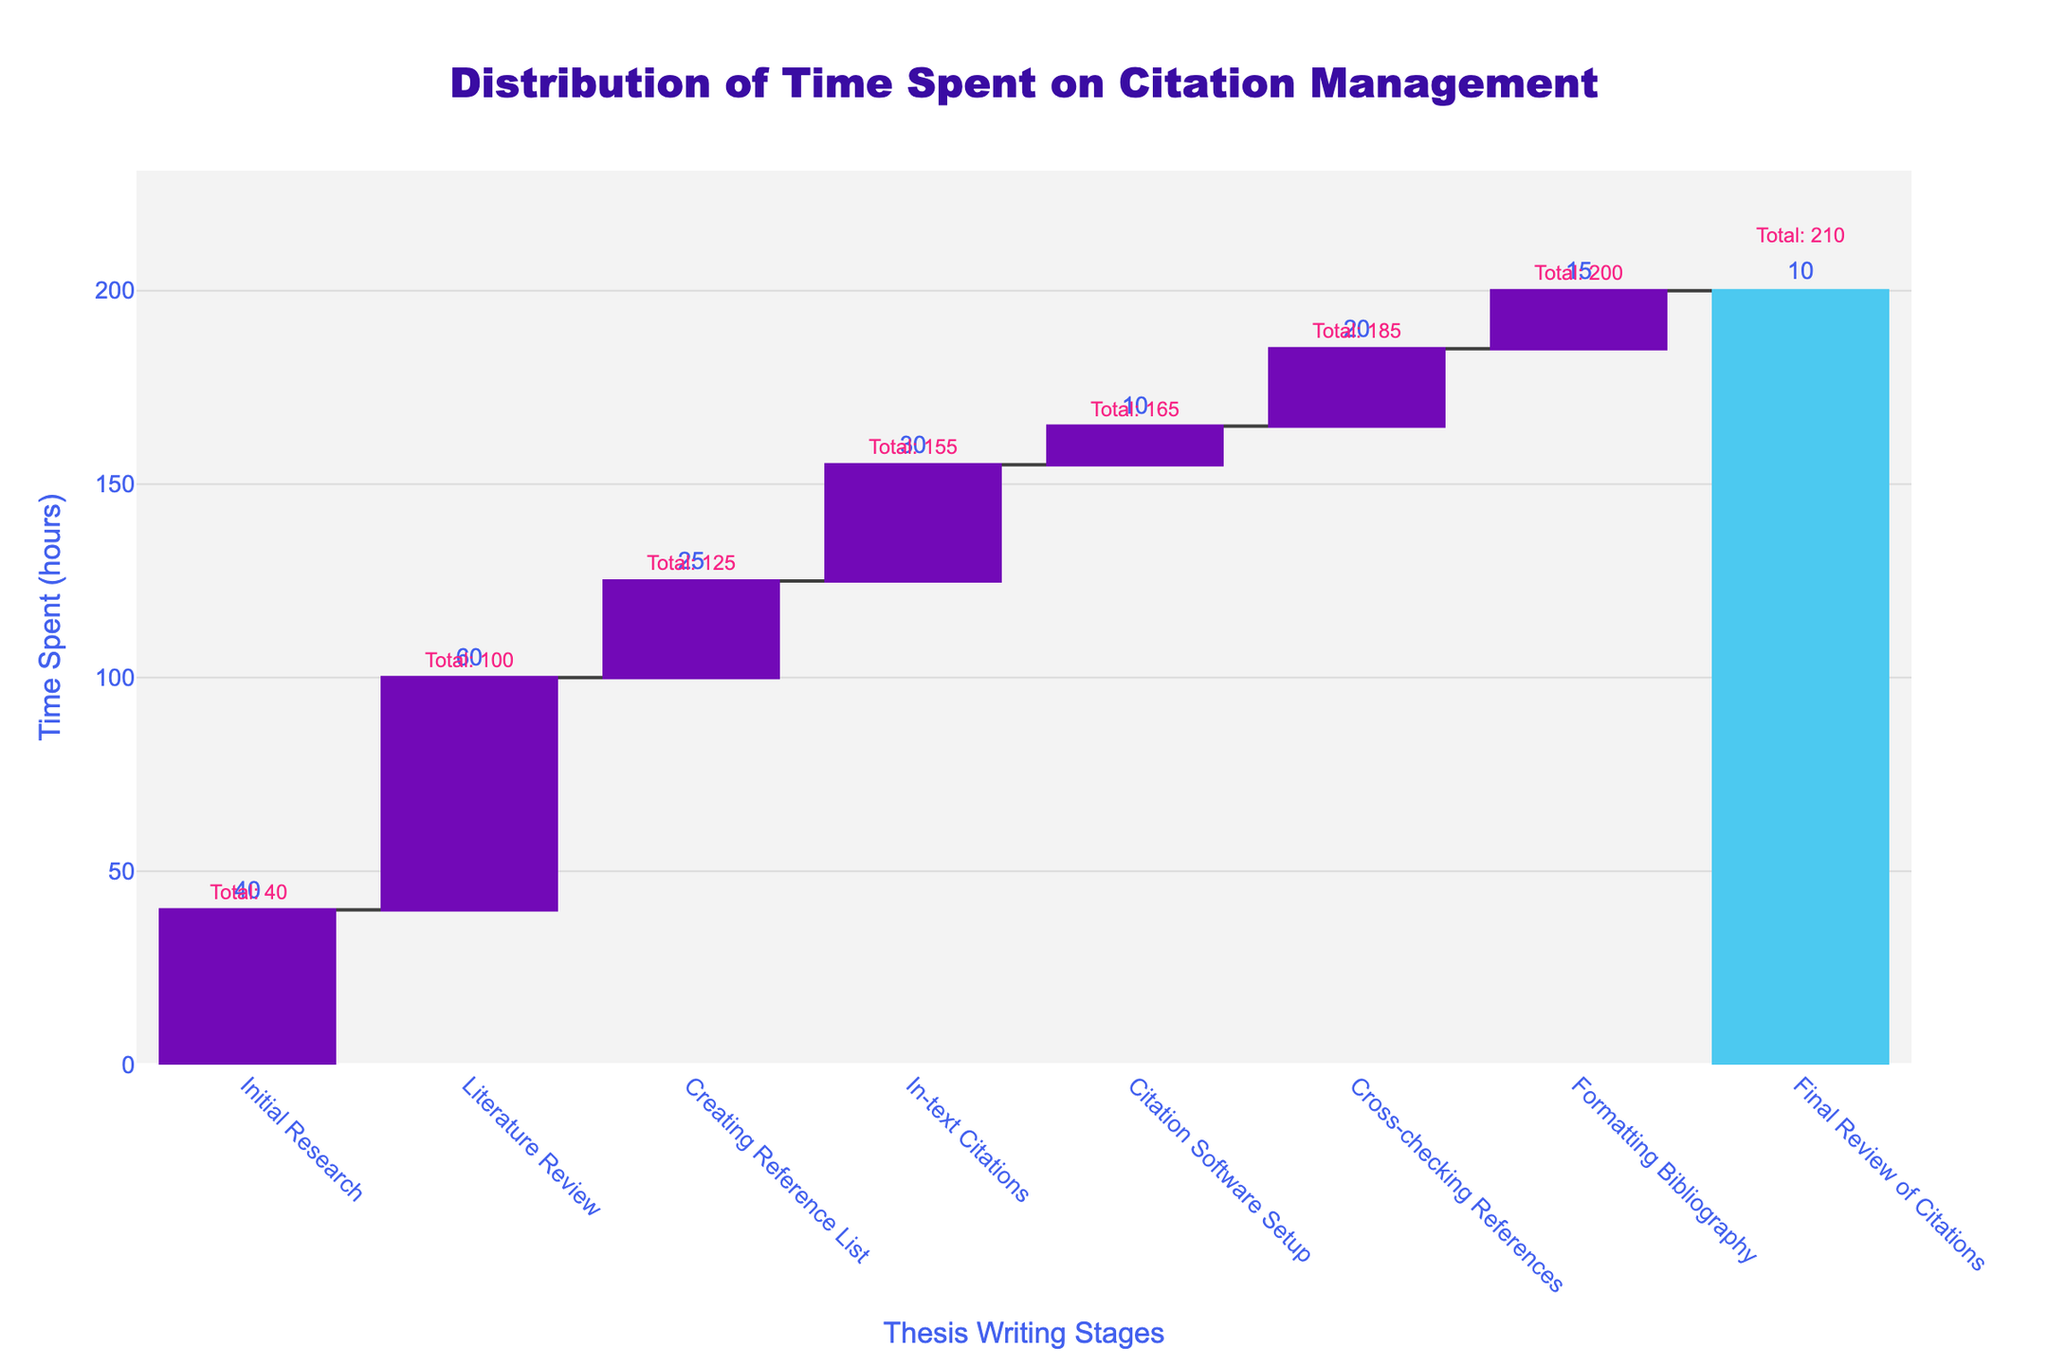What is the title of the figure? The title of the figure is provided at the top center of the plot. It reads "Distribution of Time Spent on Citation Management".
Answer: Distribution of Time Spent on Citation Management How many stages are illustrated in the waterfall chart? To find the number of stages illustrated, count the different categories on the x-axis. There are 8 stages: Initial Research, Literature Review, Creating Reference List, In-text Citations, Citation Software Setup, Cross-checking References, Formatting Bibliography, and Final Review of Citations.
Answer: 8 Which stage took the most time to complete? To identify the stage with the most time, look for the one with the highest individual contribution (height of the bar). "Literature Review" has the largest bar, indicating it took the most time.
Answer: Literature Review What is the total time spent across all citation management tasks? The total time is shown as the running total at the final stage, Final Review of Citations. The final number annotated there is 210 hours.
Answer: 210 hours How much time was spent during the 'Initial Research' phase? The 'Initial Research' phase's contribution is represented by the first bar in the waterfall chart. The text annotation shows 40 hours.
Answer: 40 hours What is the combined time spent on 'Cross-checking References' and 'Formatting Bibliography'? Add the time spent on 'Cross-checking References' and 'Formatting Bibliography' phases. 'Cross-checking References' took 20 hours and 'Formatting Bibliography' took 15 hours. 20 + 15 = 35 hours.
Answer: 35 hours Between 'Creating Reference List' and 'In-text Citations', which phase required more time? Compare the heights of the bars for 'Creating Reference List' and 'In-text Citations'. 'In-text Citations' took 30 hours, while 'Creating Reference List' took 25 hours. Thus, 'In-text Citations' required more time.
Answer: In-text Citations What percentage of the total time was spent on the 'Final Review of Citations'? The 'Final Review of Citations' took 10 hours out of the total 210 hours. The percentage is calculated as (10 / 210) * 100 ≈ 4.76%.
Answer: 4.76% Which phase shows the smallest time contribution and how much time was spent on it? The phase with the smallest bar represents the smallest time contribution. 'Citation Software Setup' has the smallest bar with a contribution of 10 hours.
Answer: Citation Software Setup, 10 hours List the stages in chronological order based on the waterfall chart. The x-axis represents the stages in chronological order as follows: Initial Research, Literature Review, Creating Reference List, In-text Citations, Citation Software Setup, Cross-checking References, Formatting Bibliography, Final Review of Citations.
Answer: Initial Research, Literature Review, Creating Reference List, In-text Citations, Citation Software Setup, Cross-checking References, Formatting Bibliography, Final Review of Citations 